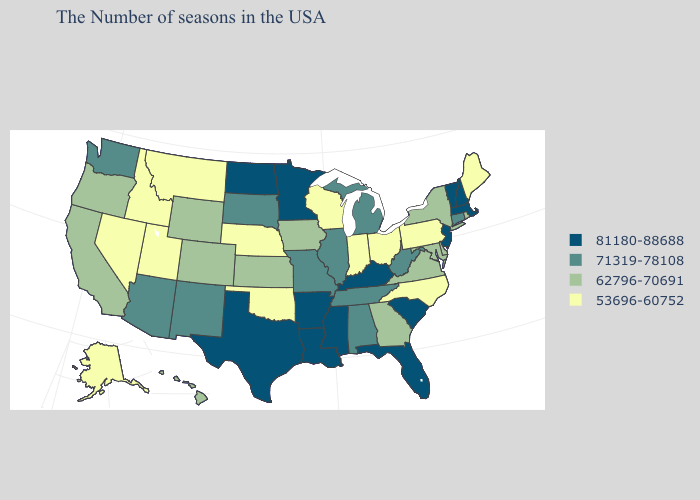What is the value of New Mexico?
Keep it brief. 71319-78108. Name the states that have a value in the range 71319-78108?
Answer briefly. Connecticut, West Virginia, Michigan, Alabama, Tennessee, Illinois, Missouri, South Dakota, New Mexico, Arizona, Washington. Does Idaho have the highest value in the West?
Give a very brief answer. No. Among the states that border North Carolina , which have the highest value?
Be succinct. South Carolina. Name the states that have a value in the range 53696-60752?
Answer briefly. Maine, Pennsylvania, North Carolina, Ohio, Indiana, Wisconsin, Nebraska, Oklahoma, Utah, Montana, Idaho, Nevada, Alaska. What is the lowest value in states that border Connecticut?
Answer briefly. 62796-70691. What is the value of Wisconsin?
Write a very short answer. 53696-60752. Name the states that have a value in the range 71319-78108?
Give a very brief answer. Connecticut, West Virginia, Michigan, Alabama, Tennessee, Illinois, Missouri, South Dakota, New Mexico, Arizona, Washington. Name the states that have a value in the range 81180-88688?
Answer briefly. Massachusetts, New Hampshire, Vermont, New Jersey, South Carolina, Florida, Kentucky, Mississippi, Louisiana, Arkansas, Minnesota, Texas, North Dakota. Name the states that have a value in the range 62796-70691?
Concise answer only. Rhode Island, New York, Delaware, Maryland, Virginia, Georgia, Iowa, Kansas, Wyoming, Colorado, California, Oregon, Hawaii. What is the highest value in states that border Florida?
Give a very brief answer. 71319-78108. How many symbols are there in the legend?
Concise answer only. 4. Which states have the highest value in the USA?
Concise answer only. Massachusetts, New Hampshire, Vermont, New Jersey, South Carolina, Florida, Kentucky, Mississippi, Louisiana, Arkansas, Minnesota, Texas, North Dakota. Does North Dakota have a higher value than New York?
Answer briefly. Yes. Which states have the lowest value in the USA?
Be succinct. Maine, Pennsylvania, North Carolina, Ohio, Indiana, Wisconsin, Nebraska, Oklahoma, Utah, Montana, Idaho, Nevada, Alaska. 